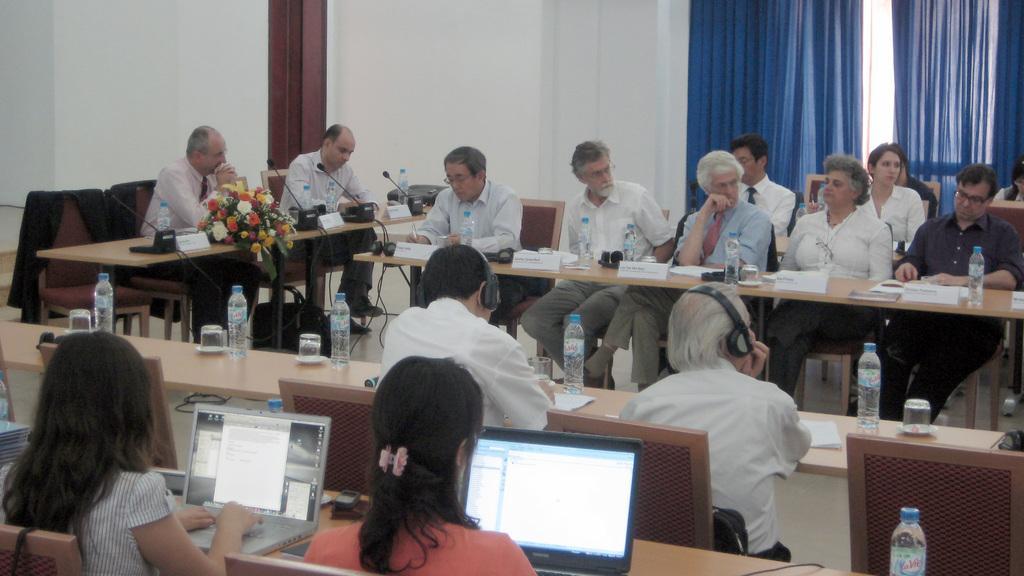Please provide a concise description of this image. In this image there are a group of persons sitting on the chair, there are tables, there are objects on the tables, there is a wall towards the top of the image, there are curtains towards the top of the image, there are two men wearing headphones. 